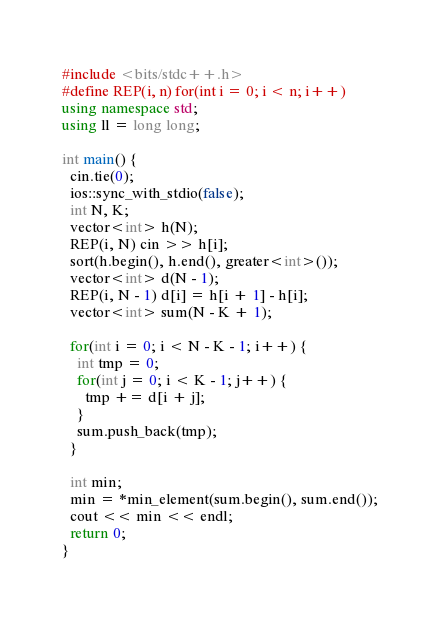<code> <loc_0><loc_0><loc_500><loc_500><_C++_>#include <bits/stdc++.h>
#define REP(i, n) for(int i = 0; i < n; i++)
using namespace std;
using ll = long long;

int main() {
  cin.tie(0);
  ios::sync_with_stdio(false);
  int N, K;
  vector<int> h(N);
  REP(i, N) cin >> h[i];
  sort(h.begin(), h.end(), greater<int>());
  vector<int> d(N - 1);
  REP(i, N - 1) d[i] = h[i + 1] - h[i];
  vector<int> sum(N - K + 1);

  for(int i = 0; i < N - K - 1; i++) {
    int tmp = 0;
    for(int j = 0; i < K - 1; j++) {
      tmp += d[i + j];
    }
    sum.push_back(tmp);
  }

  int min;
  min = *min_element(sum.begin(), sum.end());
  cout << min << endl;
  return 0;
}</code> 